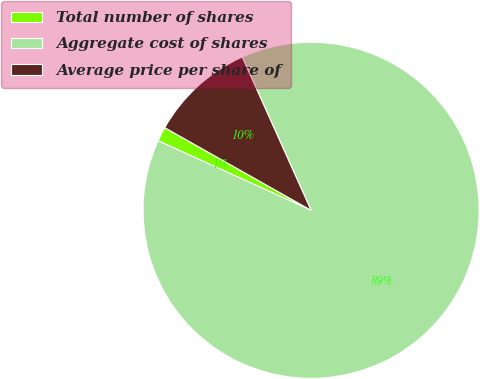<chart> <loc_0><loc_0><loc_500><loc_500><pie_chart><fcel>Total number of shares<fcel>Aggregate cost of shares<fcel>Average price per share of<nl><fcel>1.39%<fcel>88.5%<fcel>10.1%<nl></chart> 